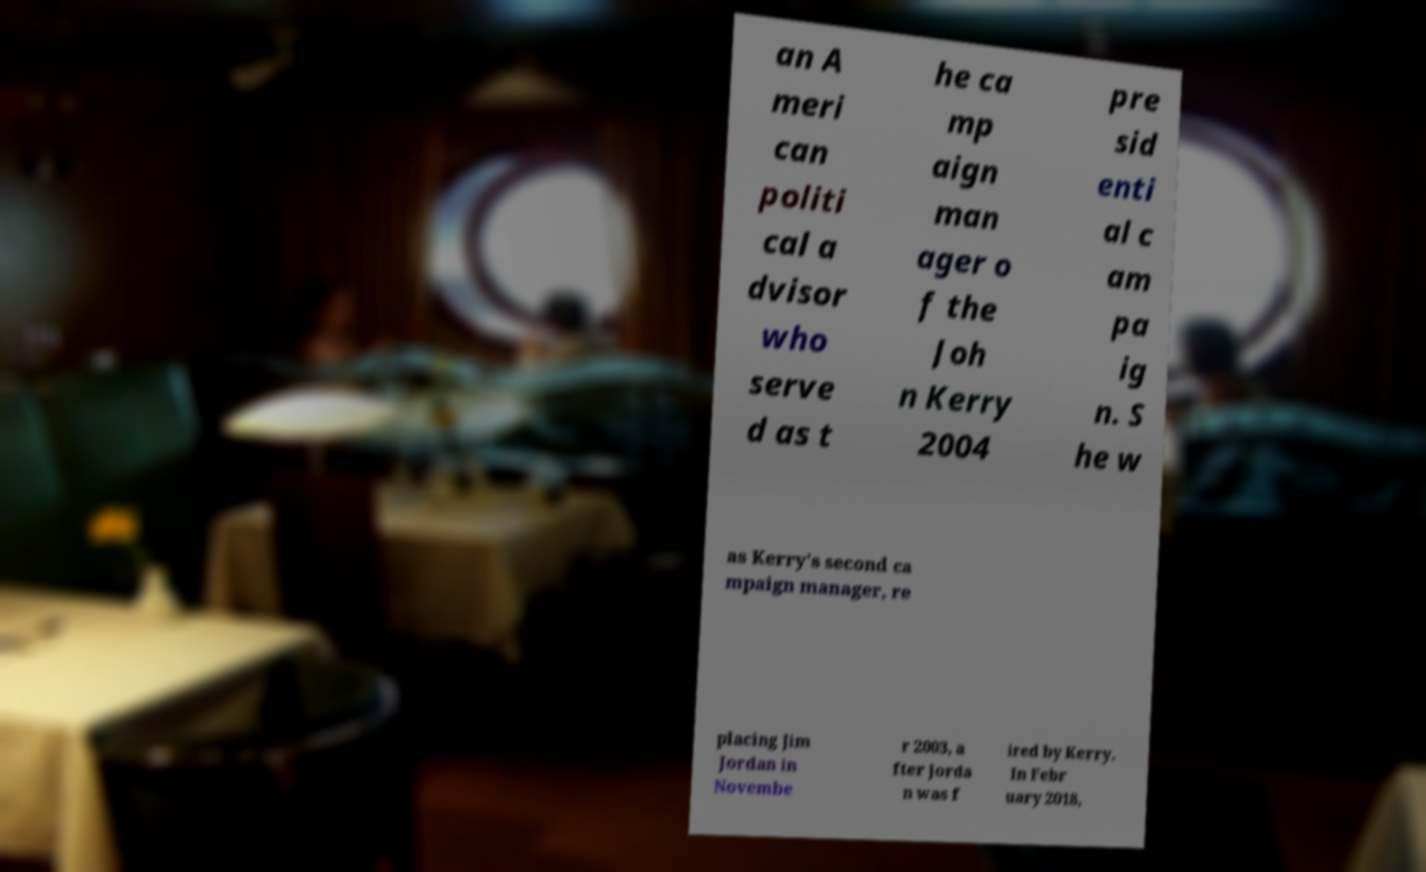For documentation purposes, I need the text within this image transcribed. Could you provide that? an A meri can politi cal a dvisor who serve d as t he ca mp aign man ager o f the Joh n Kerry 2004 pre sid enti al c am pa ig n. S he w as Kerry's second ca mpaign manager, re placing Jim Jordan in Novembe r 2003, a fter Jorda n was f ired by Kerry. In Febr uary 2018, 